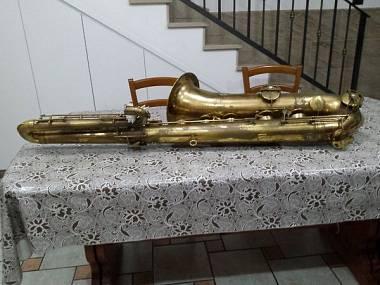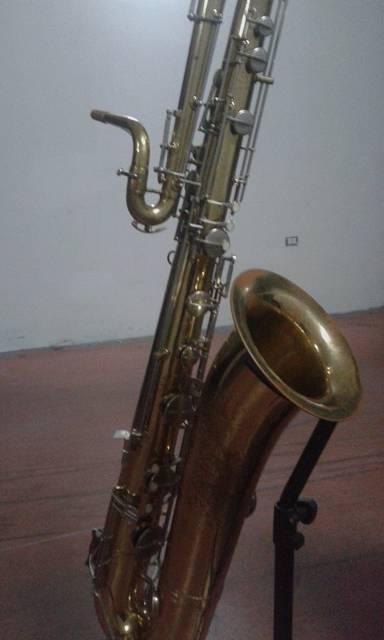The first image is the image on the left, the second image is the image on the right. Evaluate the accuracy of this statement regarding the images: "The right image shows a gold-colored saxophone displayed at an angle on off-white fabric, with its mouthpiece separated and laying near it.". Is it true? Answer yes or no. No. The first image is the image on the left, the second image is the image on the right. Given the left and right images, does the statement "A saxophone with the mouth piece removed is laying on a wrinkled tan colored cloth." hold true? Answer yes or no. No. 